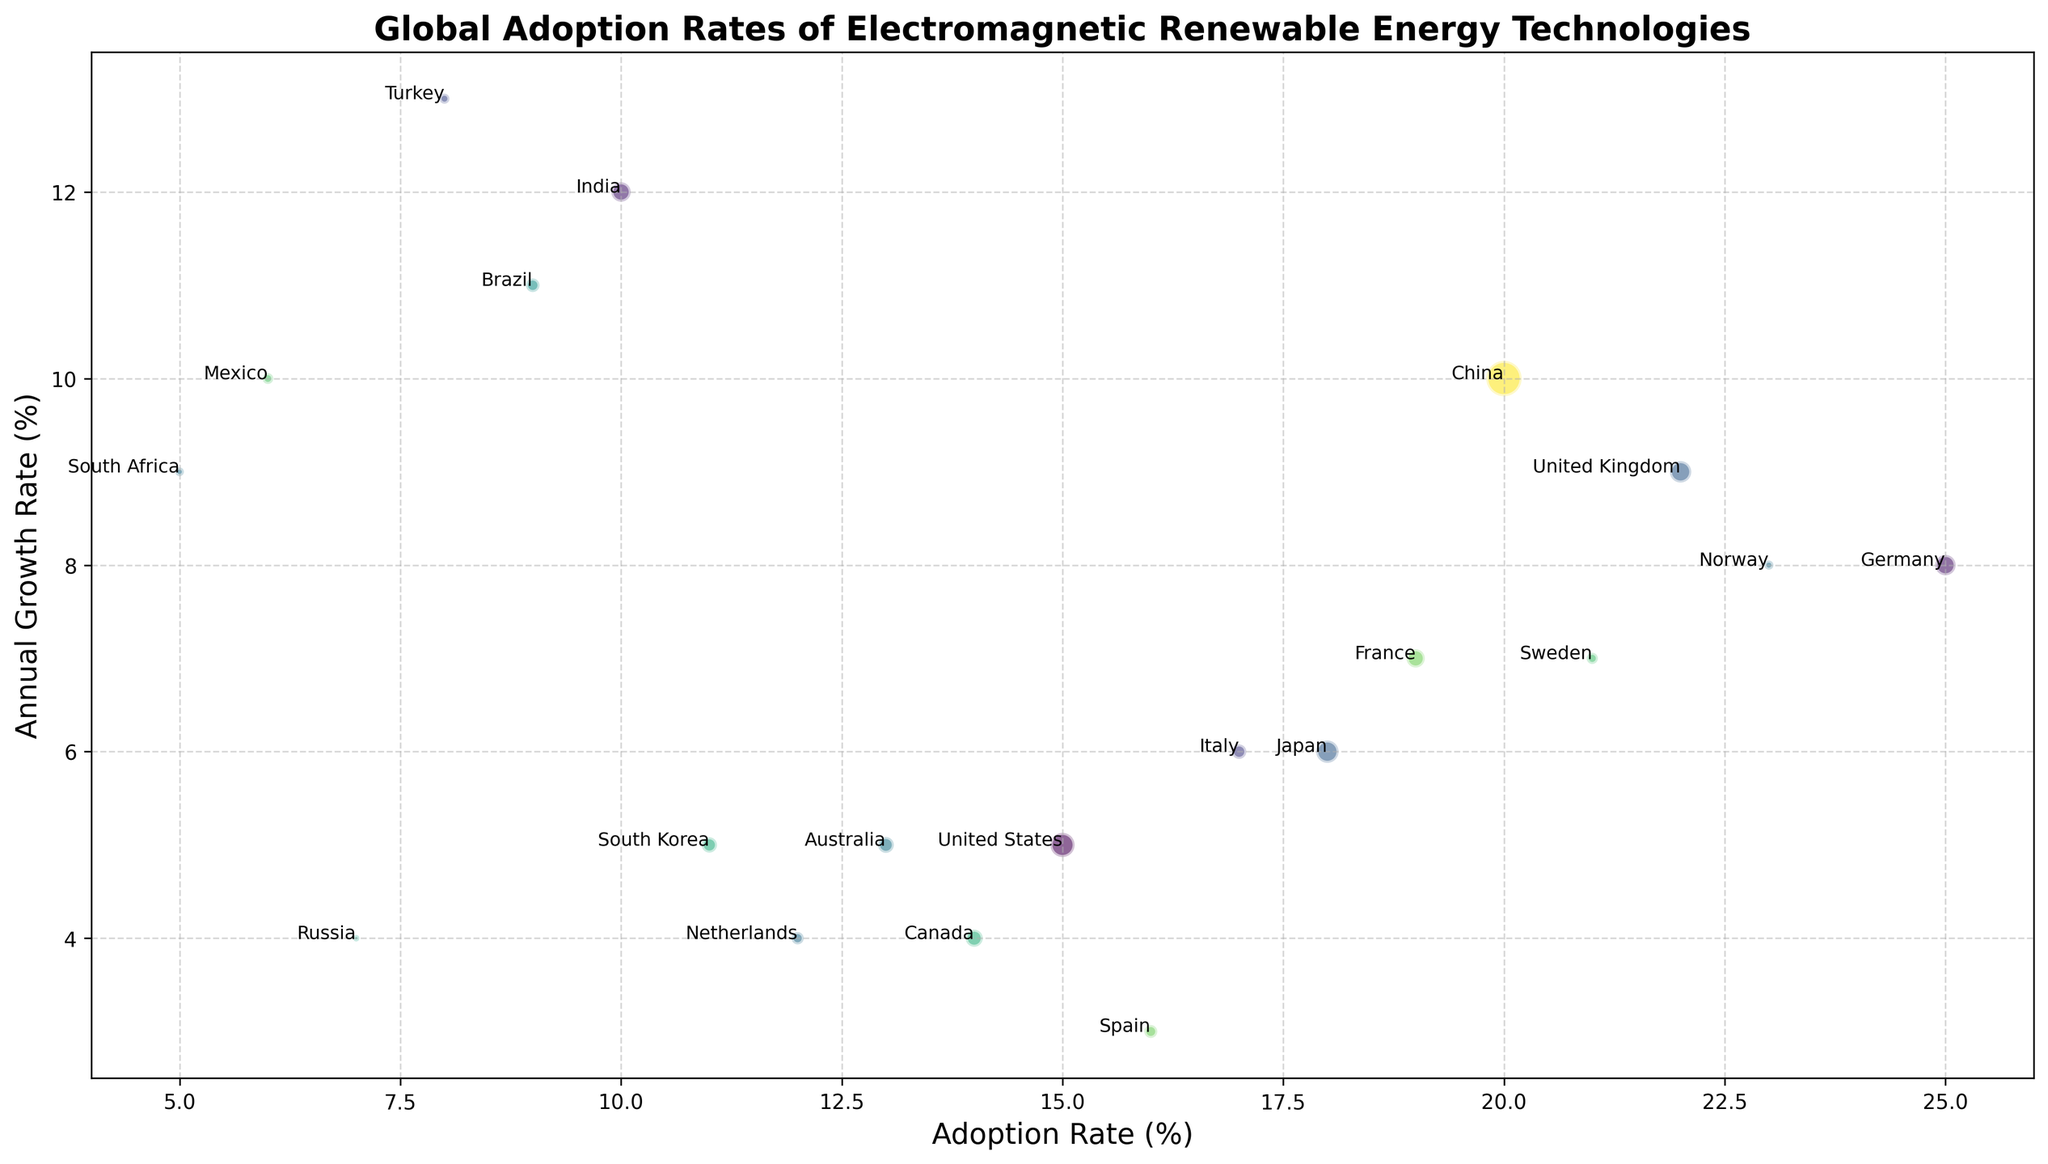What country has the highest adoption rate? By observing the position of the bubbles along the x-axis, we see that Germany has the highest adoption rate at 25%.
Answer: Germany Which country has the lowest investment level? By comparing the size of the bubbles, the smallest bubble corresponds to Russia, indicating that it has the lowest investment level.
Answer: Russia What are the adoption rates of countries with an annual growth rate above 10%? The countries with annual growth rates above 10% are India (12%), Brazil (11%), Turkey (13%), and Mexico (10%). Their adoption rates are 10% for India, 9% for Brazil, 8% for Turkey, and 6% for Mexico.
Answer: India: 10%, Brazil: 9%, Turkey: 8%, Mexico: 6% Which country has a higher adoption rate, Japan or the United Kingdom? We need to compare the positions of Japan and the United Kingdom along the x-axis. Japan has an adoption rate of 18%, and the United Kingdom has an adoption rate of 22%.
Answer: United Kingdom What is the difference in investment levels between China and the United States? China’s investment level is 150, and the United States’ investment level is 70. The difference is calculated as 150 - 70 = 80.
Answer: 80 How many countries have an annual growth rate between 5% and 10%? Countries with annual growth rates between 5% and 10% are the United States, Japan, United Kingdom, France, Canada, Sweden, South Africa, and Mexico. In total, there are 8 countries.
Answer: 8 Which country with a low investment level (< 20) has a high annual growth rate (> 8%)? By filtering the bubbles, Turkey (investment level 12) has the highest annual growth rate at 13%.
Answer: Turkey Between Brazil and Canada, which country has a higher annual growth rate? Brazil has an annual growth rate of 11%, and Canada has an annual growth rate of 4%. Thus, Brazil has a higher annual growth rate.
Answer: Brazil What is the combined adoption rate of France and Italy? The adoption rate of France is 19%, and the adoption rate of Italy is 17%. Combining these rates gives 19% + 17% = 36%.
Answer: 36% Which countries have both a lower adoption rate than Australia and an annual growth rate of 5% or more? Australia's adoption rate is 13%. Countries with lower adoption rates and annual growth rates of at least 5% are Brazil (9%, 11%), South Korea (11%, 5%), Netherlands (12%, 4%), Mexico (6%, 10%), South Africa (5%, 9%), and Russia (7%, 4%). South Korea, Brazil, Mexico, and South Africa meet both conditions.
Answer: South Korea, Brazil, Mexico, South Africa 